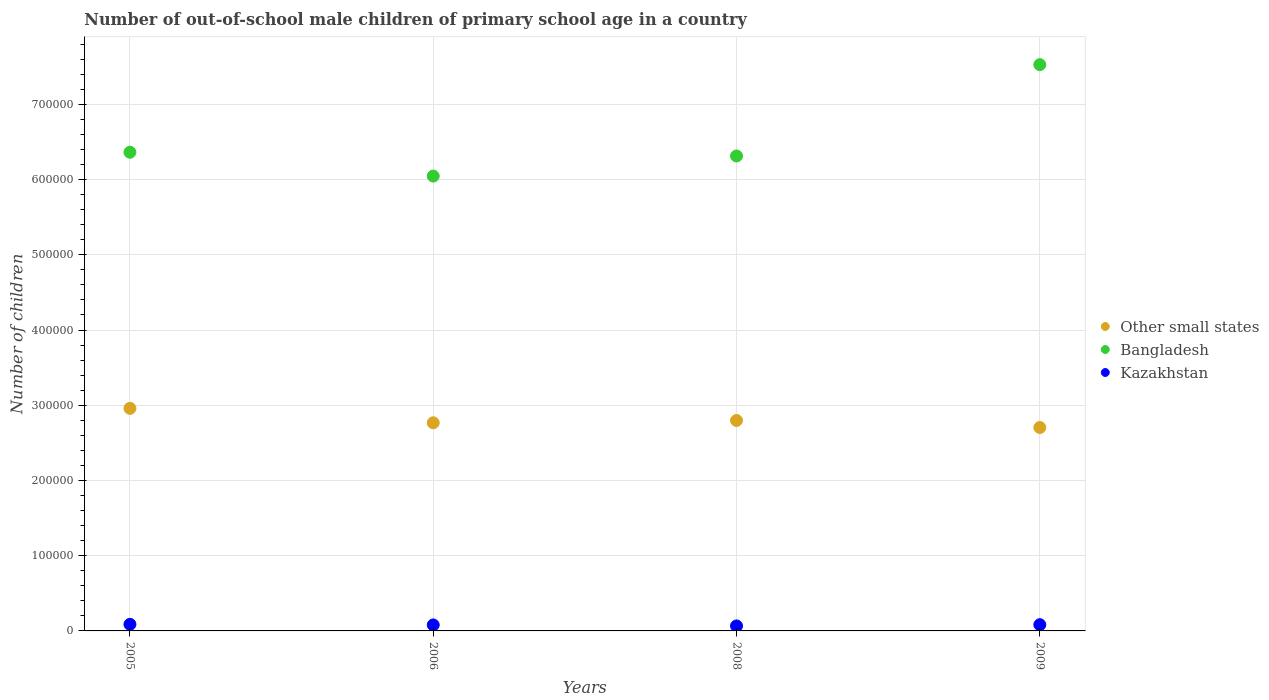How many different coloured dotlines are there?
Offer a terse response. 3. What is the number of out-of-school male children in Other small states in 2009?
Offer a very short reply. 2.70e+05. Across all years, what is the maximum number of out-of-school male children in Bangladesh?
Ensure brevity in your answer.  7.53e+05. Across all years, what is the minimum number of out-of-school male children in Kazakhstan?
Keep it short and to the point. 6640. In which year was the number of out-of-school male children in Bangladesh maximum?
Your response must be concise. 2009. In which year was the number of out-of-school male children in Kazakhstan minimum?
Make the answer very short. 2008. What is the total number of out-of-school male children in Other small states in the graph?
Your response must be concise. 1.12e+06. What is the difference between the number of out-of-school male children in Bangladesh in 2005 and that in 2009?
Make the answer very short. -1.16e+05. What is the difference between the number of out-of-school male children in Kazakhstan in 2006 and the number of out-of-school male children in Other small states in 2005?
Offer a very short reply. -2.88e+05. What is the average number of out-of-school male children in Other small states per year?
Give a very brief answer. 2.81e+05. In the year 2008, what is the difference between the number of out-of-school male children in Other small states and number of out-of-school male children in Bangladesh?
Offer a very short reply. -3.52e+05. What is the ratio of the number of out-of-school male children in Bangladesh in 2008 to that in 2009?
Your answer should be very brief. 0.84. Is the difference between the number of out-of-school male children in Other small states in 2005 and 2008 greater than the difference between the number of out-of-school male children in Bangladesh in 2005 and 2008?
Make the answer very short. Yes. What is the difference between the highest and the second highest number of out-of-school male children in Bangladesh?
Offer a terse response. 1.16e+05. What is the difference between the highest and the lowest number of out-of-school male children in Kazakhstan?
Offer a very short reply. 2119. Is it the case that in every year, the sum of the number of out-of-school male children in Kazakhstan and number of out-of-school male children in Bangladesh  is greater than the number of out-of-school male children in Other small states?
Make the answer very short. Yes. Does the number of out-of-school male children in Bangladesh monotonically increase over the years?
Your answer should be very brief. No. Is the number of out-of-school male children in Kazakhstan strictly less than the number of out-of-school male children in Other small states over the years?
Provide a short and direct response. Yes. What is the difference between two consecutive major ticks on the Y-axis?
Your answer should be compact. 1.00e+05. How many legend labels are there?
Offer a terse response. 3. What is the title of the graph?
Keep it short and to the point. Number of out-of-school male children of primary school age in a country. Does "Bulgaria" appear as one of the legend labels in the graph?
Keep it short and to the point. No. What is the label or title of the Y-axis?
Provide a succinct answer. Number of children. What is the Number of children in Other small states in 2005?
Ensure brevity in your answer.  2.96e+05. What is the Number of children in Bangladesh in 2005?
Your response must be concise. 6.36e+05. What is the Number of children of Kazakhstan in 2005?
Your answer should be compact. 8759. What is the Number of children in Other small states in 2006?
Keep it short and to the point. 2.77e+05. What is the Number of children in Bangladesh in 2006?
Give a very brief answer. 6.05e+05. What is the Number of children of Kazakhstan in 2006?
Offer a terse response. 7940. What is the Number of children in Other small states in 2008?
Your answer should be compact. 2.80e+05. What is the Number of children of Bangladesh in 2008?
Your answer should be compact. 6.31e+05. What is the Number of children in Kazakhstan in 2008?
Your answer should be compact. 6640. What is the Number of children in Other small states in 2009?
Make the answer very short. 2.70e+05. What is the Number of children of Bangladesh in 2009?
Provide a succinct answer. 7.53e+05. What is the Number of children of Kazakhstan in 2009?
Ensure brevity in your answer.  8289. Across all years, what is the maximum Number of children in Other small states?
Your answer should be very brief. 2.96e+05. Across all years, what is the maximum Number of children of Bangladesh?
Keep it short and to the point. 7.53e+05. Across all years, what is the maximum Number of children of Kazakhstan?
Keep it short and to the point. 8759. Across all years, what is the minimum Number of children in Other small states?
Your answer should be very brief. 2.70e+05. Across all years, what is the minimum Number of children in Bangladesh?
Your answer should be compact. 6.05e+05. Across all years, what is the minimum Number of children in Kazakhstan?
Your response must be concise. 6640. What is the total Number of children of Other small states in the graph?
Keep it short and to the point. 1.12e+06. What is the total Number of children of Bangladesh in the graph?
Keep it short and to the point. 2.63e+06. What is the total Number of children of Kazakhstan in the graph?
Keep it short and to the point. 3.16e+04. What is the difference between the Number of children in Other small states in 2005 and that in 2006?
Make the answer very short. 1.92e+04. What is the difference between the Number of children in Bangladesh in 2005 and that in 2006?
Keep it short and to the point. 3.17e+04. What is the difference between the Number of children in Kazakhstan in 2005 and that in 2006?
Offer a very short reply. 819. What is the difference between the Number of children in Other small states in 2005 and that in 2008?
Make the answer very short. 1.61e+04. What is the difference between the Number of children of Bangladesh in 2005 and that in 2008?
Offer a very short reply. 4960. What is the difference between the Number of children of Kazakhstan in 2005 and that in 2008?
Ensure brevity in your answer.  2119. What is the difference between the Number of children in Other small states in 2005 and that in 2009?
Make the answer very short. 2.55e+04. What is the difference between the Number of children in Bangladesh in 2005 and that in 2009?
Your answer should be very brief. -1.16e+05. What is the difference between the Number of children in Kazakhstan in 2005 and that in 2009?
Make the answer very short. 470. What is the difference between the Number of children of Other small states in 2006 and that in 2008?
Keep it short and to the point. -3104. What is the difference between the Number of children of Bangladesh in 2006 and that in 2008?
Ensure brevity in your answer.  -2.67e+04. What is the difference between the Number of children of Kazakhstan in 2006 and that in 2008?
Offer a very short reply. 1300. What is the difference between the Number of children in Other small states in 2006 and that in 2009?
Offer a very short reply. 6271. What is the difference between the Number of children of Bangladesh in 2006 and that in 2009?
Provide a short and direct response. -1.48e+05. What is the difference between the Number of children of Kazakhstan in 2006 and that in 2009?
Provide a succinct answer. -349. What is the difference between the Number of children of Other small states in 2008 and that in 2009?
Your answer should be compact. 9375. What is the difference between the Number of children of Bangladesh in 2008 and that in 2009?
Provide a succinct answer. -1.21e+05. What is the difference between the Number of children of Kazakhstan in 2008 and that in 2009?
Give a very brief answer. -1649. What is the difference between the Number of children in Other small states in 2005 and the Number of children in Bangladesh in 2006?
Provide a succinct answer. -3.09e+05. What is the difference between the Number of children in Other small states in 2005 and the Number of children in Kazakhstan in 2006?
Keep it short and to the point. 2.88e+05. What is the difference between the Number of children of Bangladesh in 2005 and the Number of children of Kazakhstan in 2006?
Provide a short and direct response. 6.28e+05. What is the difference between the Number of children of Other small states in 2005 and the Number of children of Bangladesh in 2008?
Your response must be concise. -3.36e+05. What is the difference between the Number of children in Other small states in 2005 and the Number of children in Kazakhstan in 2008?
Give a very brief answer. 2.89e+05. What is the difference between the Number of children of Bangladesh in 2005 and the Number of children of Kazakhstan in 2008?
Ensure brevity in your answer.  6.30e+05. What is the difference between the Number of children in Other small states in 2005 and the Number of children in Bangladesh in 2009?
Give a very brief answer. -4.57e+05. What is the difference between the Number of children of Other small states in 2005 and the Number of children of Kazakhstan in 2009?
Make the answer very short. 2.88e+05. What is the difference between the Number of children of Bangladesh in 2005 and the Number of children of Kazakhstan in 2009?
Offer a terse response. 6.28e+05. What is the difference between the Number of children of Other small states in 2006 and the Number of children of Bangladesh in 2008?
Provide a short and direct response. -3.55e+05. What is the difference between the Number of children in Other small states in 2006 and the Number of children in Kazakhstan in 2008?
Your response must be concise. 2.70e+05. What is the difference between the Number of children in Bangladesh in 2006 and the Number of children in Kazakhstan in 2008?
Ensure brevity in your answer.  5.98e+05. What is the difference between the Number of children in Other small states in 2006 and the Number of children in Bangladesh in 2009?
Your answer should be compact. -4.76e+05. What is the difference between the Number of children of Other small states in 2006 and the Number of children of Kazakhstan in 2009?
Provide a succinct answer. 2.68e+05. What is the difference between the Number of children in Bangladesh in 2006 and the Number of children in Kazakhstan in 2009?
Provide a short and direct response. 5.96e+05. What is the difference between the Number of children of Other small states in 2008 and the Number of children of Bangladesh in 2009?
Give a very brief answer. -4.73e+05. What is the difference between the Number of children in Other small states in 2008 and the Number of children in Kazakhstan in 2009?
Ensure brevity in your answer.  2.72e+05. What is the difference between the Number of children in Bangladesh in 2008 and the Number of children in Kazakhstan in 2009?
Offer a terse response. 6.23e+05. What is the average Number of children of Other small states per year?
Keep it short and to the point. 2.81e+05. What is the average Number of children in Bangladesh per year?
Provide a succinct answer. 6.56e+05. What is the average Number of children of Kazakhstan per year?
Offer a terse response. 7907. In the year 2005, what is the difference between the Number of children of Other small states and Number of children of Bangladesh?
Give a very brief answer. -3.40e+05. In the year 2005, what is the difference between the Number of children of Other small states and Number of children of Kazakhstan?
Make the answer very short. 2.87e+05. In the year 2005, what is the difference between the Number of children of Bangladesh and Number of children of Kazakhstan?
Provide a succinct answer. 6.28e+05. In the year 2006, what is the difference between the Number of children in Other small states and Number of children in Bangladesh?
Your response must be concise. -3.28e+05. In the year 2006, what is the difference between the Number of children of Other small states and Number of children of Kazakhstan?
Ensure brevity in your answer.  2.69e+05. In the year 2006, what is the difference between the Number of children of Bangladesh and Number of children of Kazakhstan?
Offer a terse response. 5.97e+05. In the year 2008, what is the difference between the Number of children in Other small states and Number of children in Bangladesh?
Ensure brevity in your answer.  -3.52e+05. In the year 2008, what is the difference between the Number of children of Other small states and Number of children of Kazakhstan?
Offer a terse response. 2.73e+05. In the year 2008, what is the difference between the Number of children in Bangladesh and Number of children in Kazakhstan?
Your answer should be compact. 6.25e+05. In the year 2009, what is the difference between the Number of children in Other small states and Number of children in Bangladesh?
Your answer should be very brief. -4.82e+05. In the year 2009, what is the difference between the Number of children of Other small states and Number of children of Kazakhstan?
Make the answer very short. 2.62e+05. In the year 2009, what is the difference between the Number of children in Bangladesh and Number of children in Kazakhstan?
Give a very brief answer. 7.45e+05. What is the ratio of the Number of children in Other small states in 2005 to that in 2006?
Your answer should be compact. 1.07. What is the ratio of the Number of children of Bangladesh in 2005 to that in 2006?
Your response must be concise. 1.05. What is the ratio of the Number of children in Kazakhstan in 2005 to that in 2006?
Provide a short and direct response. 1.1. What is the ratio of the Number of children in Other small states in 2005 to that in 2008?
Provide a succinct answer. 1.06. What is the ratio of the Number of children of Bangladesh in 2005 to that in 2008?
Offer a very short reply. 1.01. What is the ratio of the Number of children of Kazakhstan in 2005 to that in 2008?
Your response must be concise. 1.32. What is the ratio of the Number of children in Other small states in 2005 to that in 2009?
Keep it short and to the point. 1.09. What is the ratio of the Number of children of Bangladesh in 2005 to that in 2009?
Provide a short and direct response. 0.85. What is the ratio of the Number of children of Kazakhstan in 2005 to that in 2009?
Your answer should be very brief. 1.06. What is the ratio of the Number of children in Other small states in 2006 to that in 2008?
Offer a terse response. 0.99. What is the ratio of the Number of children of Bangladesh in 2006 to that in 2008?
Offer a very short reply. 0.96. What is the ratio of the Number of children in Kazakhstan in 2006 to that in 2008?
Offer a terse response. 1.2. What is the ratio of the Number of children in Other small states in 2006 to that in 2009?
Make the answer very short. 1.02. What is the ratio of the Number of children of Bangladesh in 2006 to that in 2009?
Provide a succinct answer. 0.8. What is the ratio of the Number of children of Kazakhstan in 2006 to that in 2009?
Your response must be concise. 0.96. What is the ratio of the Number of children of Other small states in 2008 to that in 2009?
Your response must be concise. 1.03. What is the ratio of the Number of children in Bangladesh in 2008 to that in 2009?
Keep it short and to the point. 0.84. What is the ratio of the Number of children of Kazakhstan in 2008 to that in 2009?
Keep it short and to the point. 0.8. What is the difference between the highest and the second highest Number of children in Other small states?
Give a very brief answer. 1.61e+04. What is the difference between the highest and the second highest Number of children in Bangladesh?
Your answer should be compact. 1.16e+05. What is the difference between the highest and the second highest Number of children in Kazakhstan?
Provide a succinct answer. 470. What is the difference between the highest and the lowest Number of children in Other small states?
Provide a succinct answer. 2.55e+04. What is the difference between the highest and the lowest Number of children in Bangladesh?
Provide a succinct answer. 1.48e+05. What is the difference between the highest and the lowest Number of children in Kazakhstan?
Offer a very short reply. 2119. 